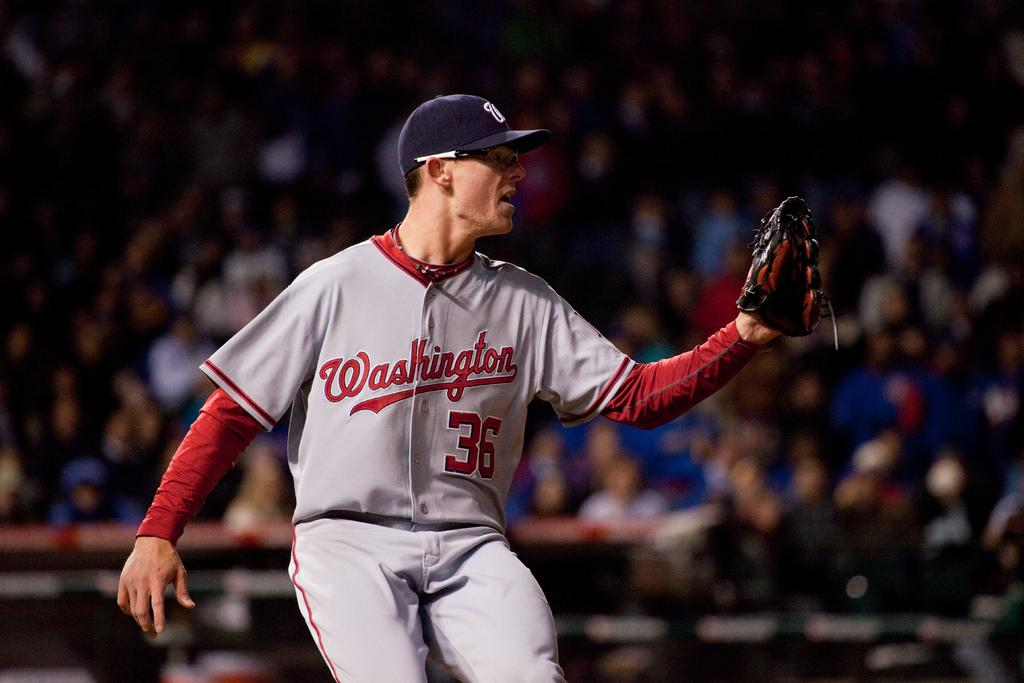<image>
Share a concise interpretation of the image provided. Player number 36 is on the team from Washington. 